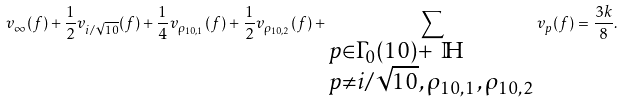Convert formula to latex. <formula><loc_0><loc_0><loc_500><loc_500>v _ { \infty } ( f ) + \frac { 1 } { 2 } v _ { i / \sqrt { 1 0 } } ( f ) + \frac { 1 } { 4 } v _ { \rho _ { 1 0 , 1 } } ( f ) + \frac { 1 } { 2 } v _ { \rho _ { 1 0 , 2 } } ( f ) + \sum _ { \begin{subarray} { c } p \in \Gamma _ { 0 } ( 1 0 ) + \ \mathbb { H } \\ p \ne i / \sqrt { 1 0 } , \, \rho _ { 1 0 , 1 } , \, \rho _ { 1 0 , 2 } \end{subarray} } v _ { p } ( f ) = \frac { 3 k } { 8 } .</formula> 